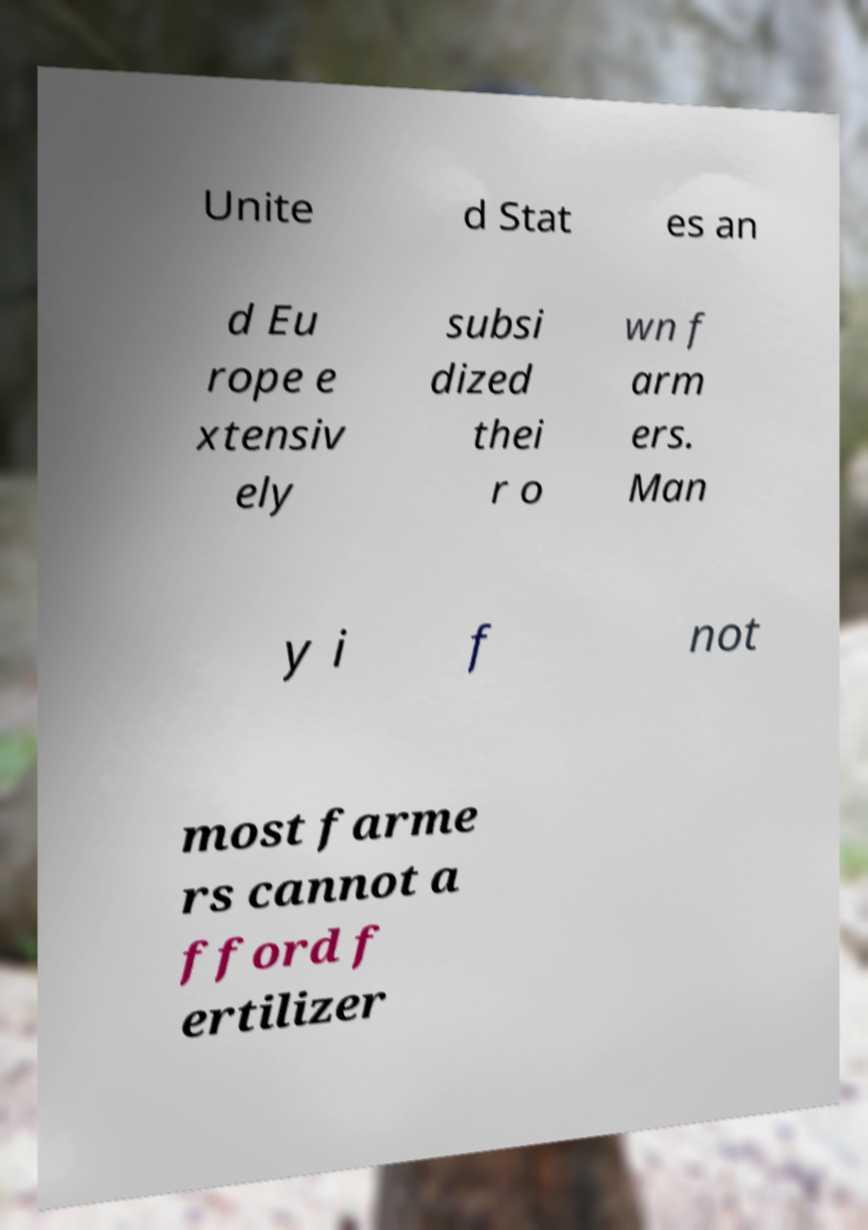Could you assist in decoding the text presented in this image and type it out clearly? Unite d Stat es an d Eu rope e xtensiv ely subsi dized thei r o wn f arm ers. Man y i f not most farme rs cannot a fford f ertilizer 